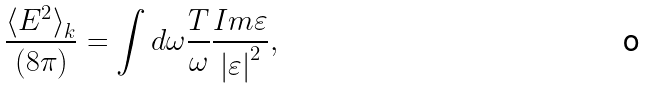<formula> <loc_0><loc_0><loc_500><loc_500>\frac { { \langle E ^ { 2 } \rangle } _ { k } } { ( 8 \pi ) } = \int d \omega \frac { T } { \omega } \frac { I m \varepsilon } { { | \varepsilon | } ^ { 2 } } ,</formula> 